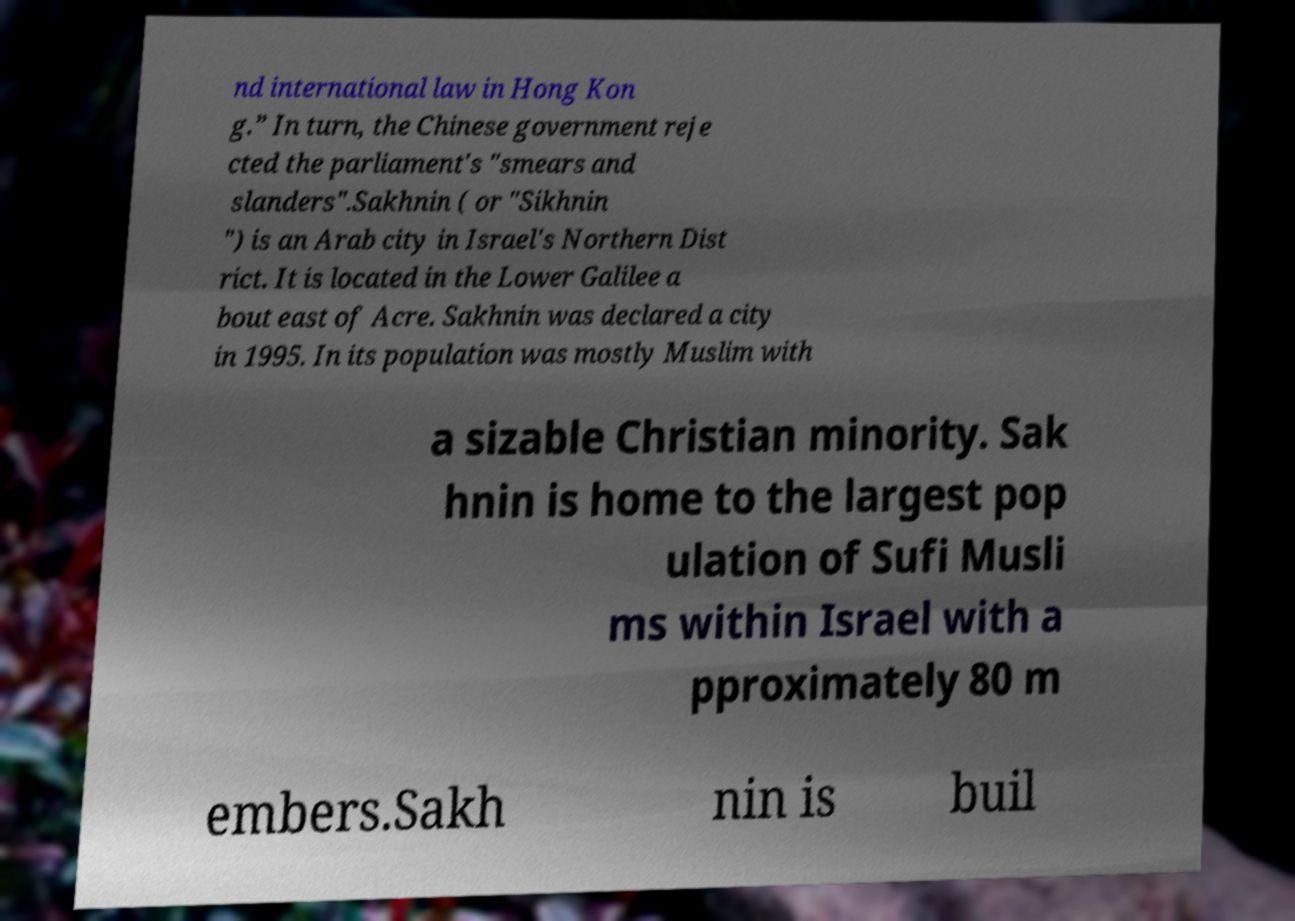Could you extract and type out the text from this image? nd international law in Hong Kon g.” In turn, the Chinese government reje cted the parliament's "smears and slanders".Sakhnin ( or "Sikhnin ") is an Arab city in Israel's Northern Dist rict. It is located in the Lower Galilee a bout east of Acre. Sakhnin was declared a city in 1995. In its population was mostly Muslim with a sizable Christian minority. Sak hnin is home to the largest pop ulation of Sufi Musli ms within Israel with a pproximately 80 m embers.Sakh nin is buil 